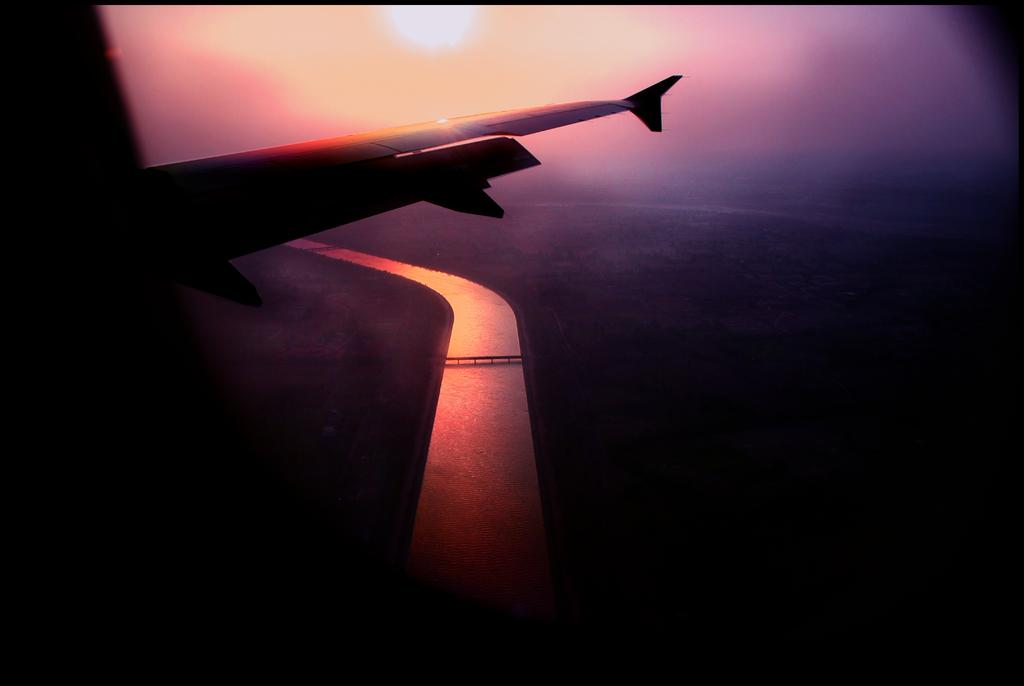What is the main subject of the image? The main subject of the image is a wing of a flight. What can be seen at the bottom of the image? There is water visible at the bottom of the image. Is there any structure that crosses the water? Yes, there is a bridge across the water. What is visible in the background of the image? The sky is visible in the background of the image. Can you see any fairies flying around the bridge in the image? There are no fairies present in the image. What type of bee can be seen buzzing near the water in the image? There are no bees present in the image. 